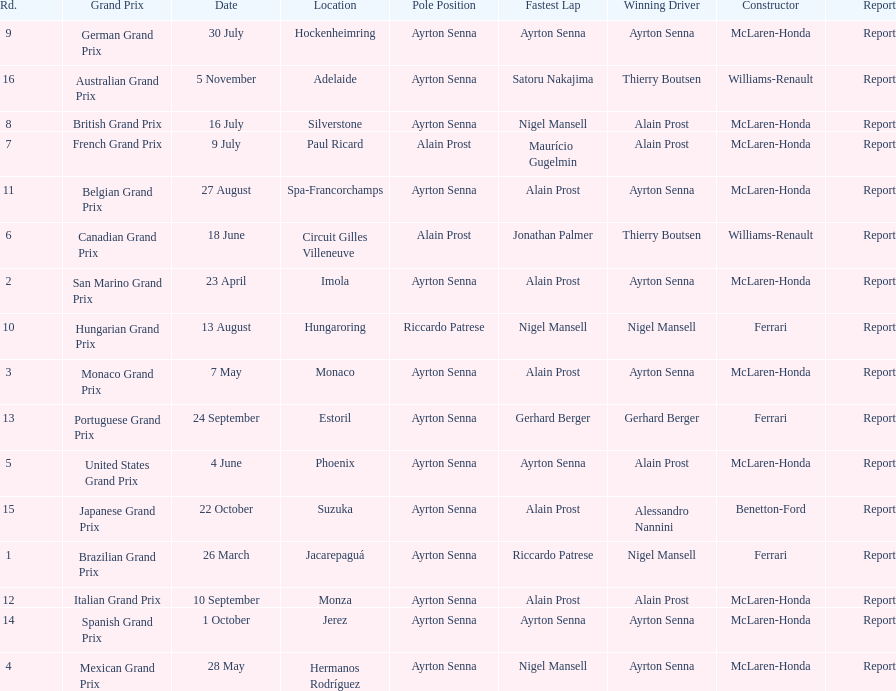Could you help me parse every detail presented in this table? {'header': ['Rd.', 'Grand Prix', 'Date', 'Location', 'Pole Position', 'Fastest Lap', 'Winning Driver', 'Constructor', 'Report'], 'rows': [['9', 'German Grand Prix', '30 July', 'Hockenheimring', 'Ayrton Senna', 'Ayrton Senna', 'Ayrton Senna', 'McLaren-Honda', 'Report'], ['16', 'Australian Grand Prix', '5 November', 'Adelaide', 'Ayrton Senna', 'Satoru Nakajima', 'Thierry Boutsen', 'Williams-Renault', 'Report'], ['8', 'British Grand Prix', '16 July', 'Silverstone', 'Ayrton Senna', 'Nigel Mansell', 'Alain Prost', 'McLaren-Honda', 'Report'], ['7', 'French Grand Prix', '9 July', 'Paul Ricard', 'Alain Prost', 'Maurício Gugelmin', 'Alain Prost', 'McLaren-Honda', 'Report'], ['11', 'Belgian Grand Prix', '27 August', 'Spa-Francorchamps', 'Ayrton Senna', 'Alain Prost', 'Ayrton Senna', 'McLaren-Honda', 'Report'], ['6', 'Canadian Grand Prix', '18 June', 'Circuit Gilles Villeneuve', 'Alain Prost', 'Jonathan Palmer', 'Thierry Boutsen', 'Williams-Renault', 'Report'], ['2', 'San Marino Grand Prix', '23 April', 'Imola', 'Ayrton Senna', 'Alain Prost', 'Ayrton Senna', 'McLaren-Honda', 'Report'], ['10', 'Hungarian Grand Prix', '13 August', 'Hungaroring', 'Riccardo Patrese', 'Nigel Mansell', 'Nigel Mansell', 'Ferrari', 'Report'], ['3', 'Monaco Grand Prix', '7 May', 'Monaco', 'Ayrton Senna', 'Alain Prost', 'Ayrton Senna', 'McLaren-Honda', 'Report'], ['13', 'Portuguese Grand Prix', '24 September', 'Estoril', 'Ayrton Senna', 'Gerhard Berger', 'Gerhard Berger', 'Ferrari', 'Report'], ['5', 'United States Grand Prix', '4 June', 'Phoenix', 'Ayrton Senna', 'Ayrton Senna', 'Alain Prost', 'McLaren-Honda', 'Report'], ['15', 'Japanese Grand Prix', '22 October', 'Suzuka', 'Ayrton Senna', 'Alain Prost', 'Alessandro Nannini', 'Benetton-Ford', 'Report'], ['1', 'Brazilian Grand Prix', '26 March', 'Jacarepaguá', 'Ayrton Senna', 'Riccardo Patrese', 'Nigel Mansell', 'Ferrari', 'Report'], ['12', 'Italian Grand Prix', '10 September', 'Monza', 'Ayrton Senna', 'Alain Prost', 'Alain Prost', 'McLaren-Honda', 'Report'], ['14', 'Spanish Grand Prix', '1 October', 'Jerez', 'Ayrton Senna', 'Ayrton Senna', 'Ayrton Senna', 'McLaren-Honda', 'Report'], ['4', 'Mexican Grand Prix', '28 May', 'Hermanos Rodríguez', 'Ayrton Senna', 'Nigel Mansell', 'Ayrton Senna', 'McLaren-Honda', 'Report']]} What grand prix was before the san marino grand prix? Brazilian Grand Prix. 